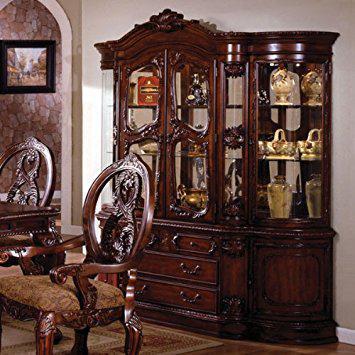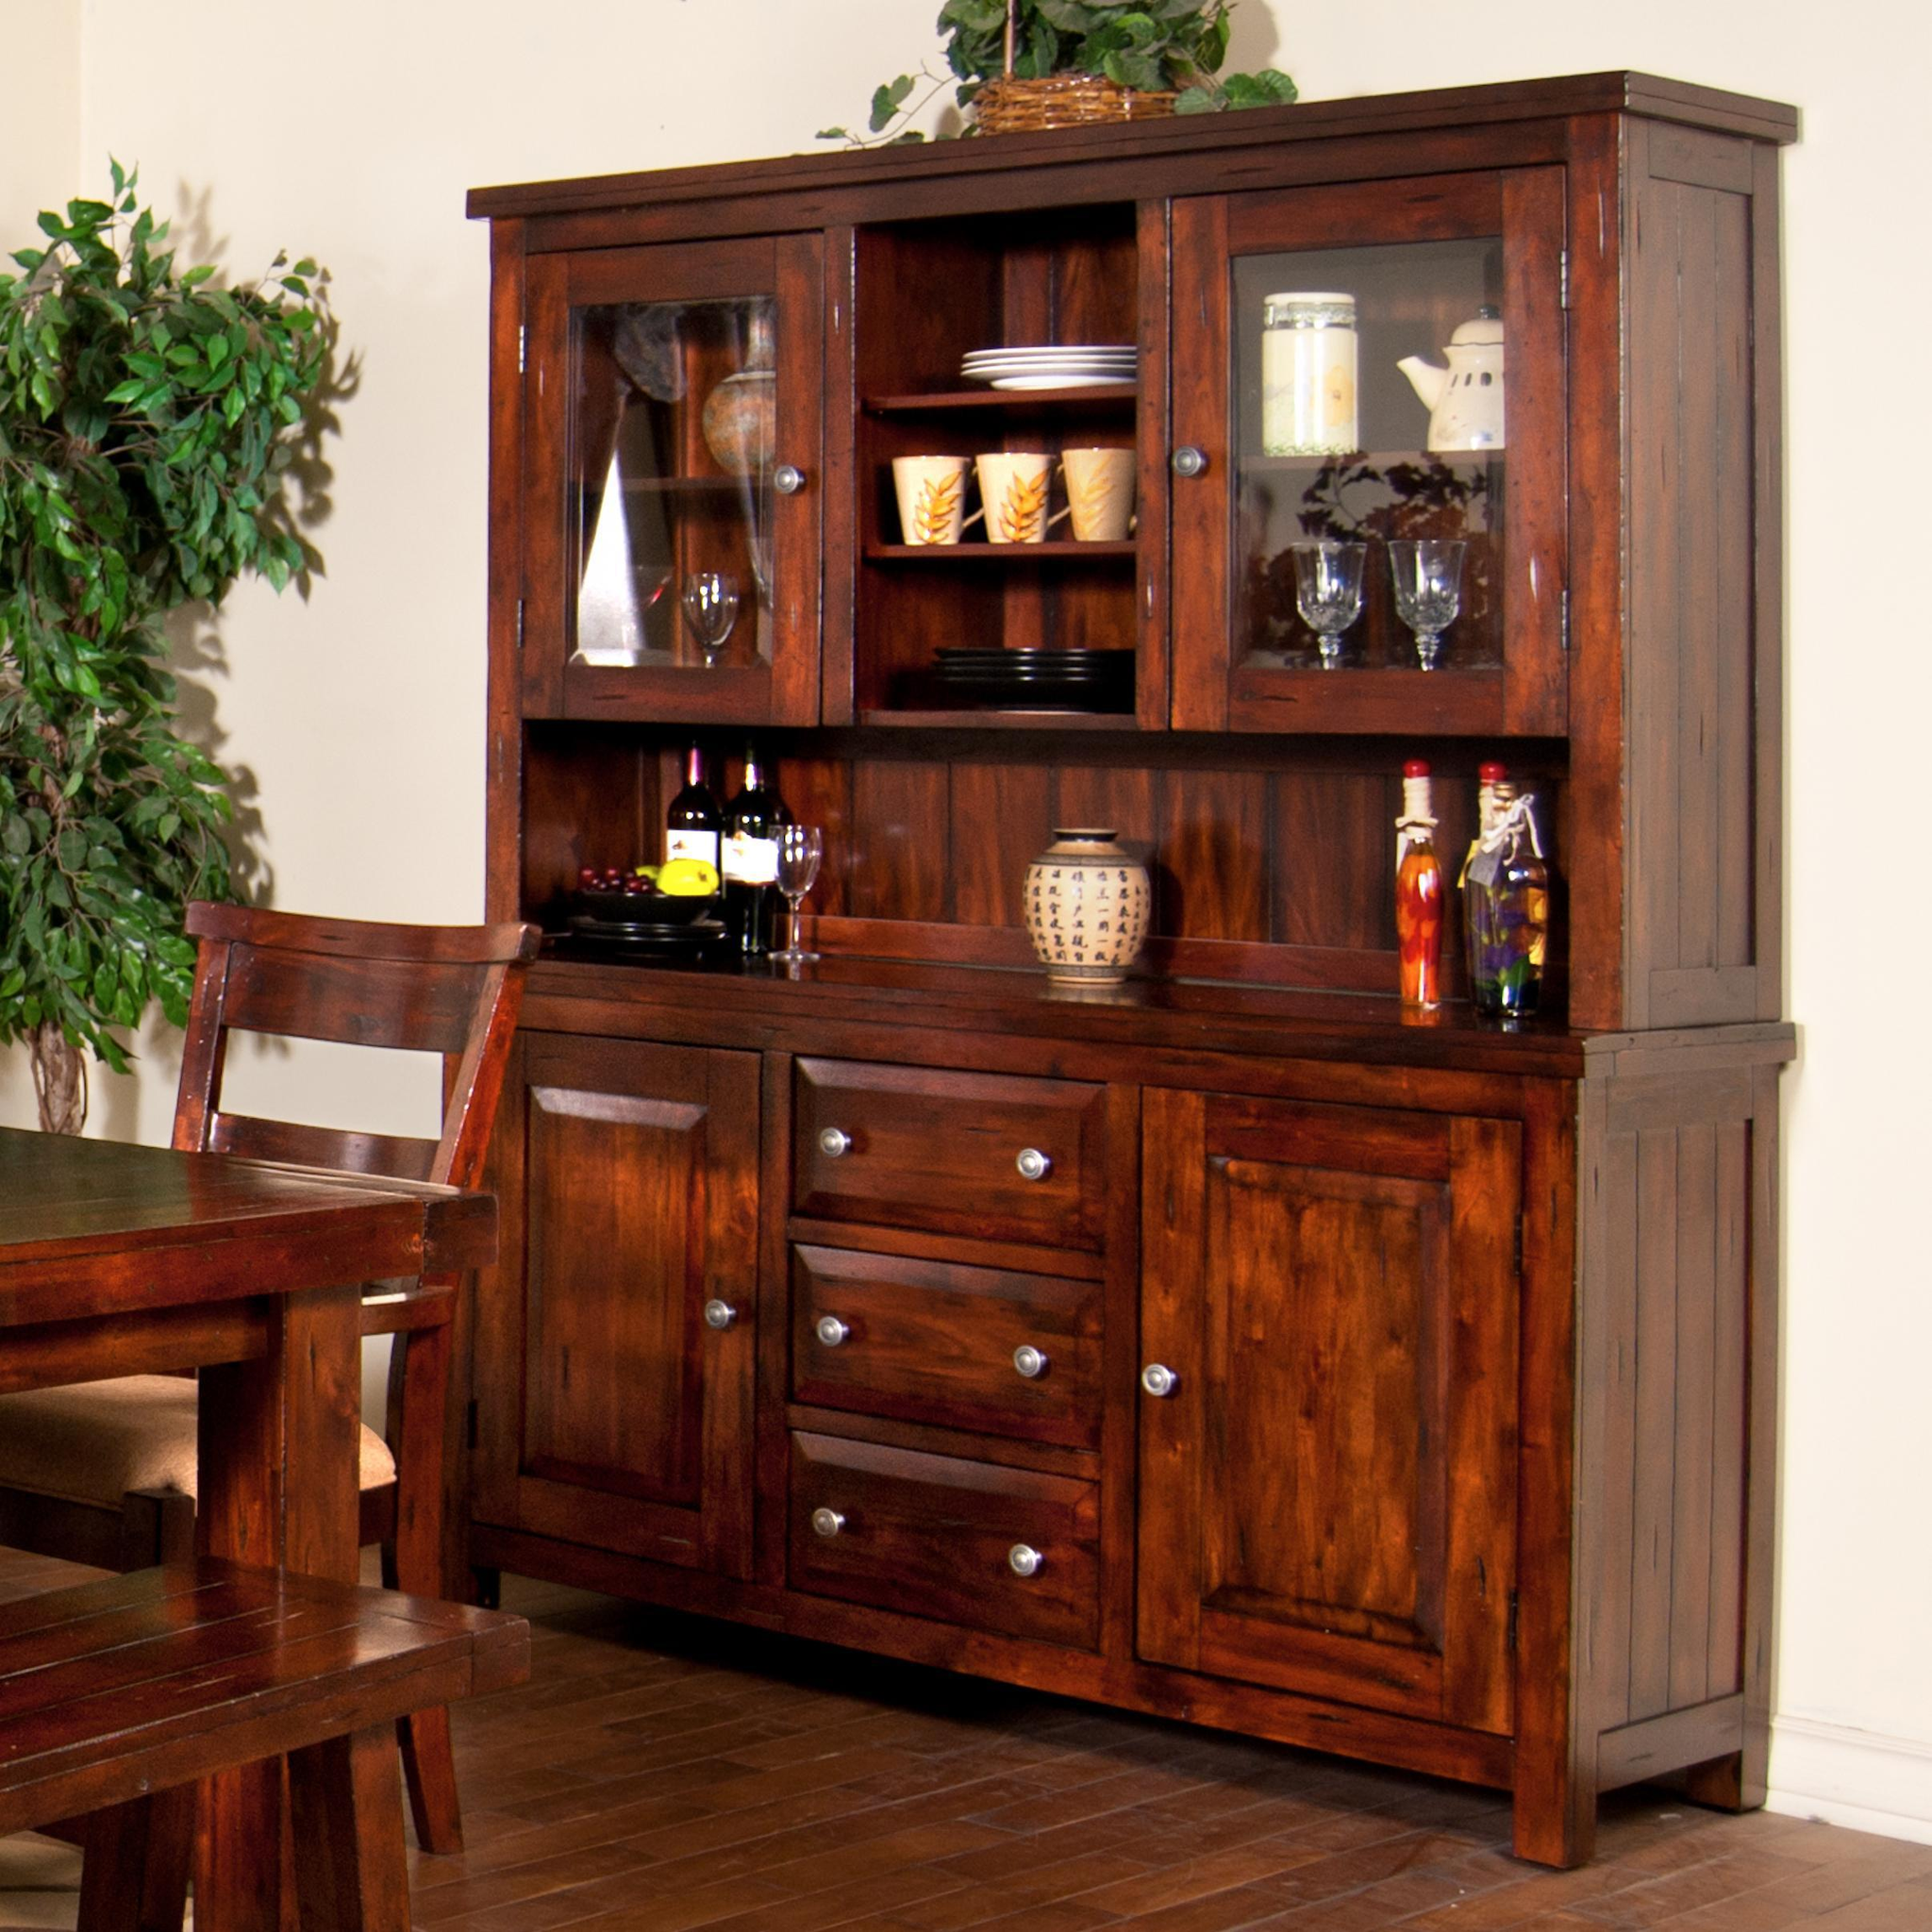The first image is the image on the left, the second image is the image on the right. Given the left and right images, does the statement "One of these images contains a completely empty hutch, and all of these images are on a plain white background." hold true? Answer yes or no. No. 